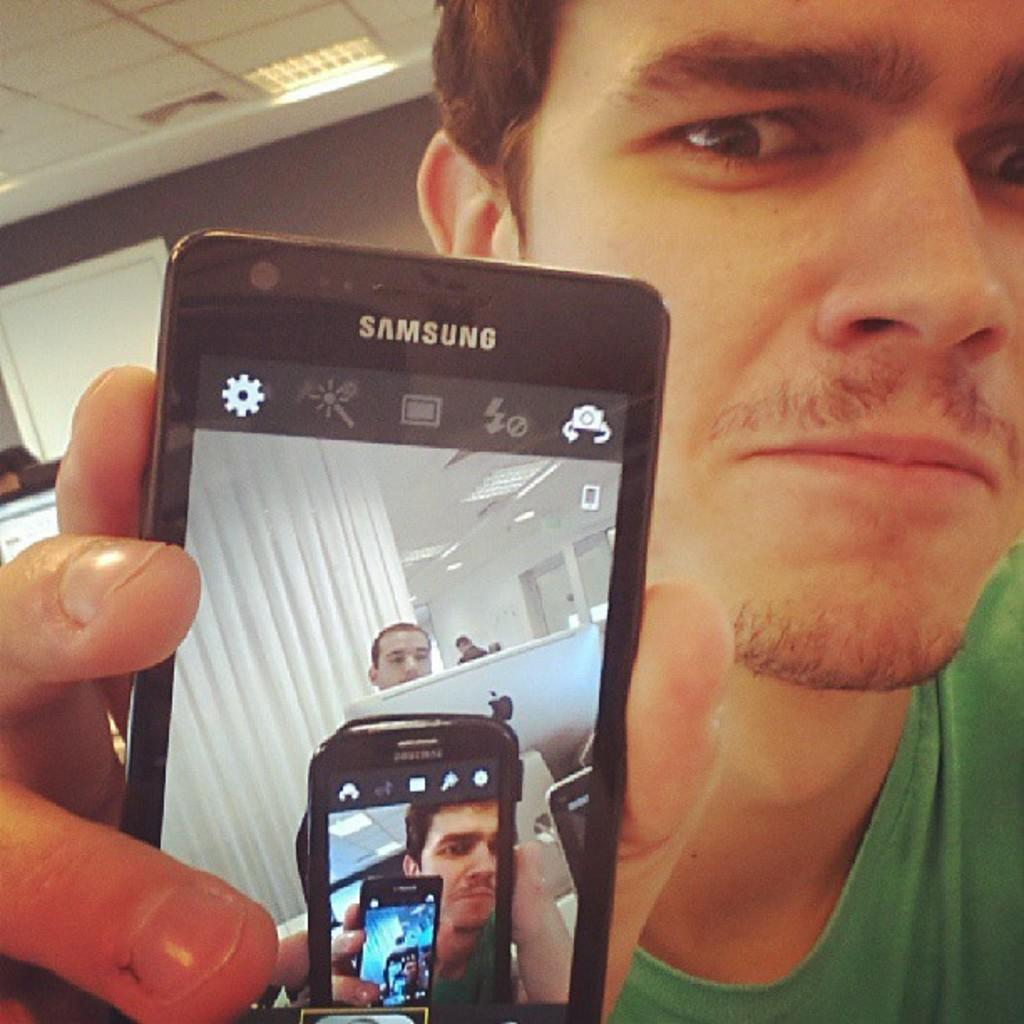<image>
Create a compact narrative representing the image presented. A person holds a Samsung cell phone showing the image of him and the phone on the screen multiple times. 